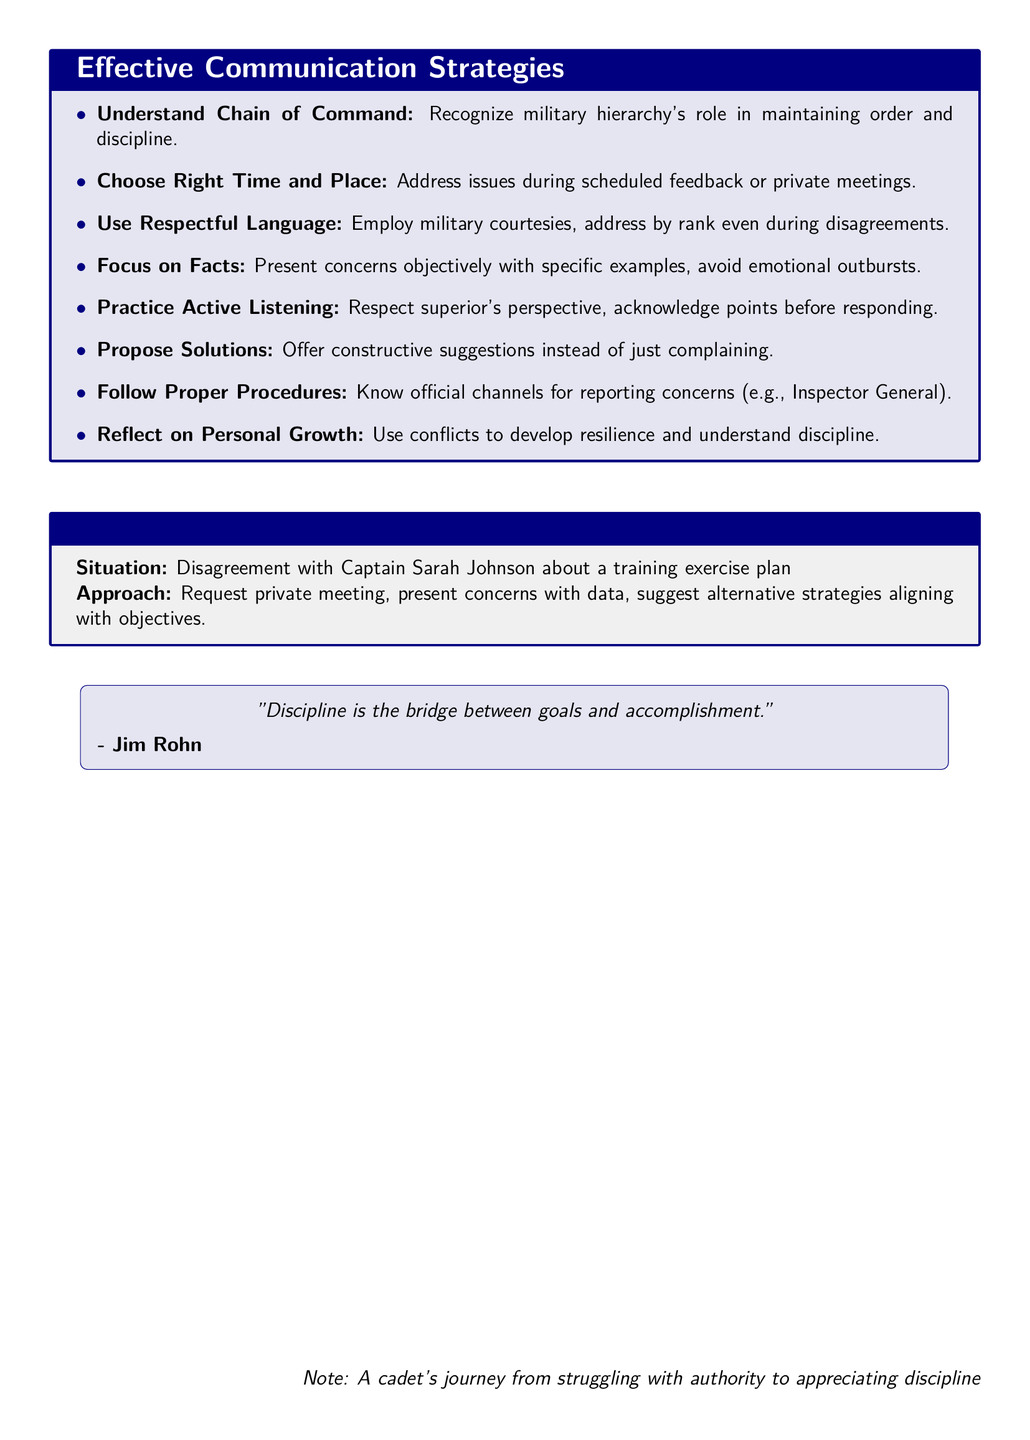What is the title of the document? The title is given at the beginning of the document and summarizes its main focus.
Answer: Effective Communication Strategies for Addressing Conflicts with Superior Officers What is one key point about language? The document specifies the importance of using respectful language when communicating with superiors.
Answer: Use Respectful Language When should you address issues according to the notes? The notes indicate that there are specific times to address issues, such as during certain sessions.
Answer: Choose the Right Time and Place What should be avoided when presenting concerns? The document highlights specific behaviors that should be avoided during discussions.
Answer: Emotional outbursts What does the example scenario involve? The scenario illustrates a conflict situation concerning a specific military officer and a training plan.
Answer: Disagreement with Captain Sarah Johnson about a training exercise plan What does the quote emphasize? The quote included in the document relates to the significance of discipline in achieving goals.
Answer: Discipline is the bridge between goals and accomplishment What is recommended after understanding a conflict? The notes suggest a personal approach to growth in relation to conflicts.
Answer: Reflect on Personal Growth How many key points are presented in the document? The document enumerates key strategies to formulate effective communication, contributing to the clarity of its advice.
Answer: Eight 